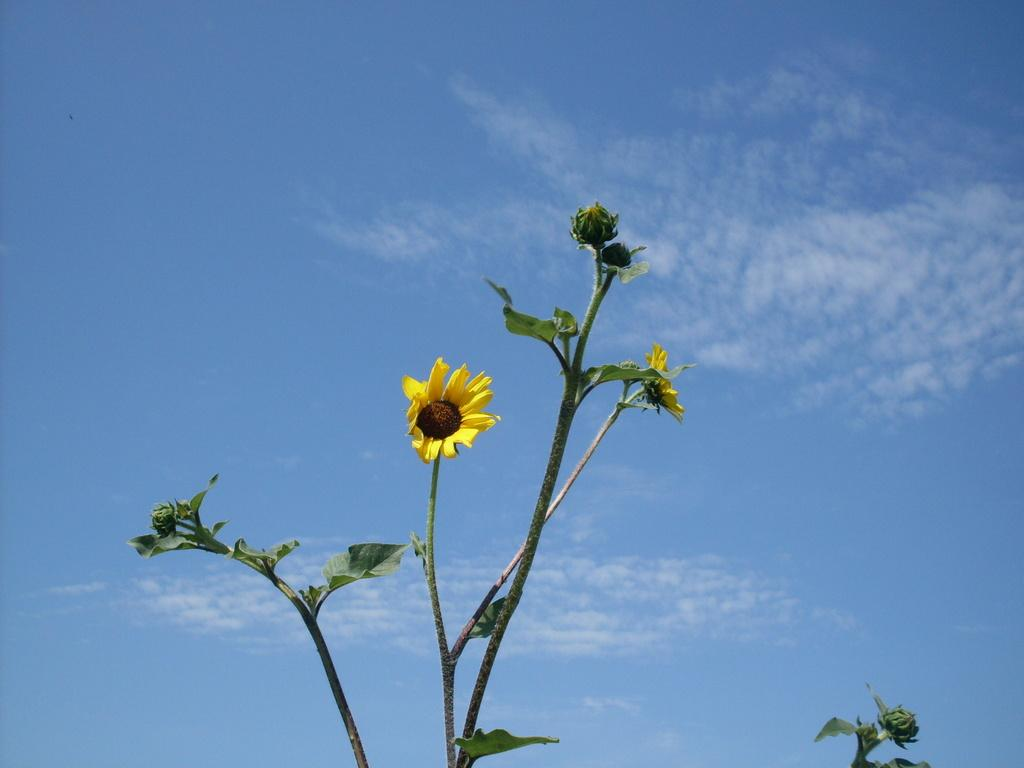What is the main subject of the image? The main subject of the image is plants with flowers. Can you describe the flowers in the image? The flowers are located in the center of the image. What can be seen in the background of the image? There are clouds in the sky in the background of the image. How many gold ladybugs can be seen on the flowers in the image? There are no ladybugs, gold or otherwise, present on the flowers in the image. 